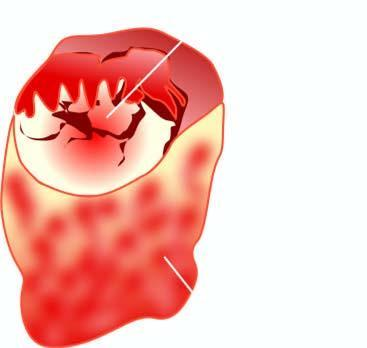s reticulin framework grey-white soft?
Answer the question using a single word or phrase. No 